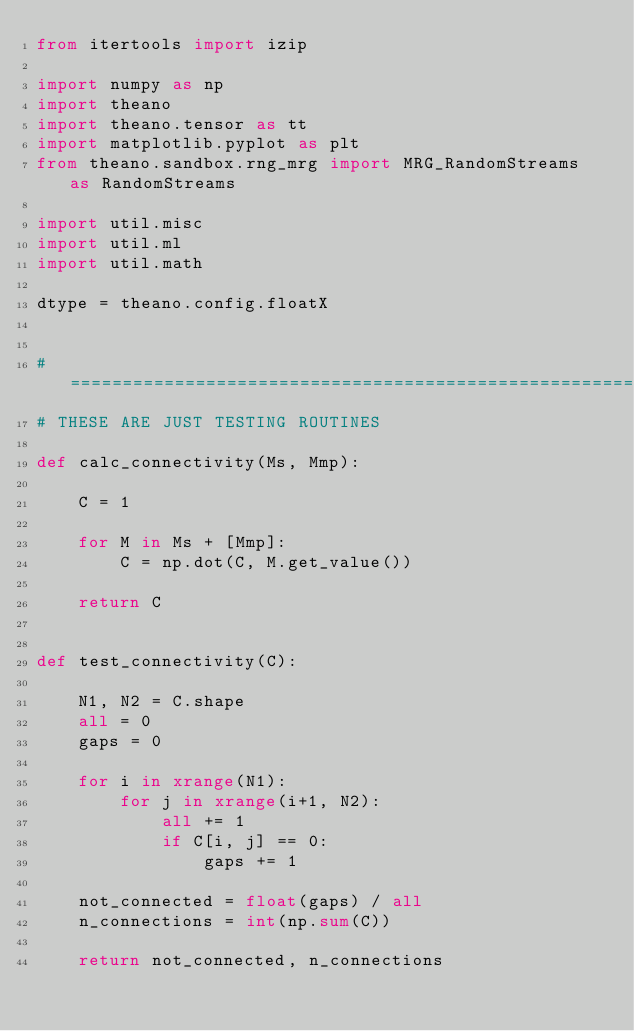Convert code to text. <code><loc_0><loc_0><loc_500><loc_500><_Python_>from itertools import izip

import numpy as np
import theano
import theano.tensor as tt
import matplotlib.pyplot as plt
from theano.sandbox.rng_mrg import MRG_RandomStreams as RandomStreams

import util.misc
import util.ml
import util.math

dtype = theano.config.floatX


# ========================================================================
# THESE ARE JUST TESTING ROUTINES

def calc_connectivity(Ms, Mmp):

    C = 1

    for M in Ms + [Mmp]:
        C = np.dot(C, M.get_value())

    return C


def test_connectivity(C):

    N1, N2 = C.shape
    all = 0
    gaps = 0

    for i in xrange(N1):
        for j in xrange(i+1, N2):
            all += 1
            if C[i, j] == 0:
                gaps += 1

    not_connected = float(gaps) / all
    n_connections = int(np.sum(C))

    return not_connected, n_connections

</code> 